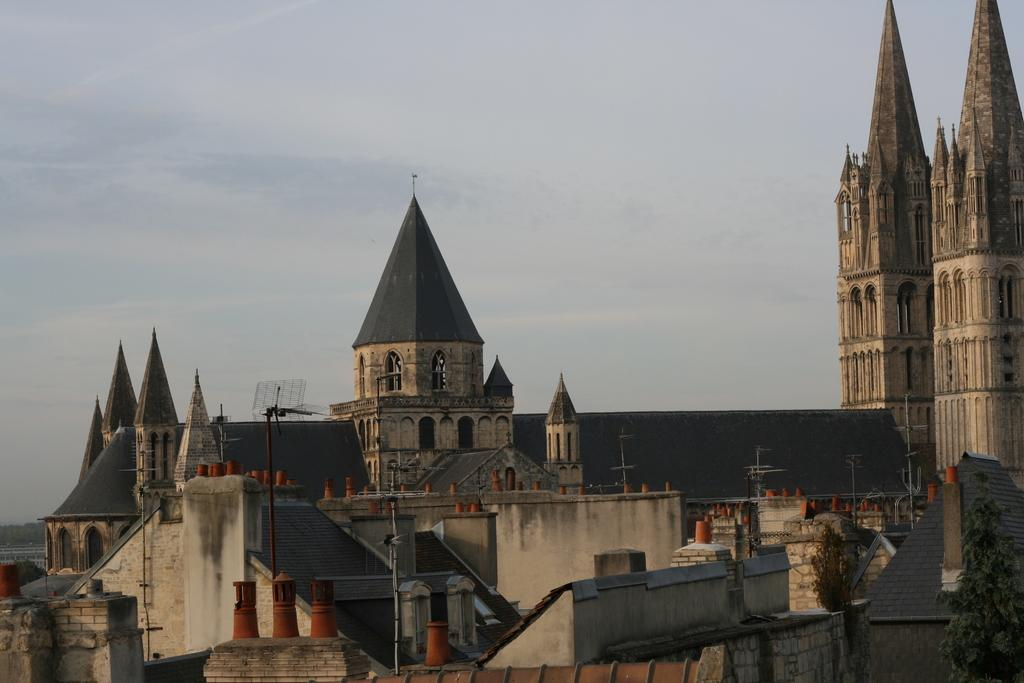What type of structures can be seen in the image? There are buildings in the image. Where is the antenna located in the image? The antenna is on the left side of the image. What is visible at the top of the image? The sky is visible at the top of the image. Can you tell me how many drawers are in the image? There are no drawers present in the image. What type of bird is sitting on the roof of the building in the image? There is no bird, specifically a hen, present in the image. 